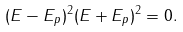Convert formula to latex. <formula><loc_0><loc_0><loc_500><loc_500>( E - E _ { p } ) ^ { 2 } ( E + E _ { p } ) ^ { 2 } = 0 .</formula> 